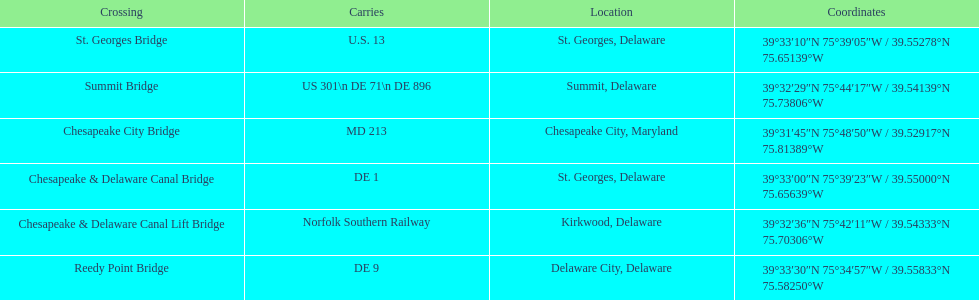Which crossing carries the most routes (e.g., de 1)? Summit Bridge. 